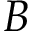<formula> <loc_0><loc_0><loc_500><loc_500>B</formula> 